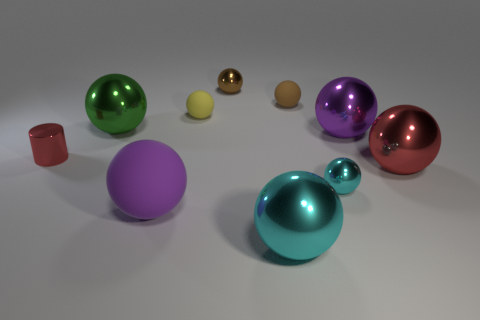How do the different colors of the spheres influence the mood of this scene? The varied colors of the spheres contribute to a vibrant and dynamic mood. The cool tones of the blue and purple spheres convey a sense of calm, while the warmer red and orange spheres add a touch of energy, creating a balanced and engaging atmosphere. 